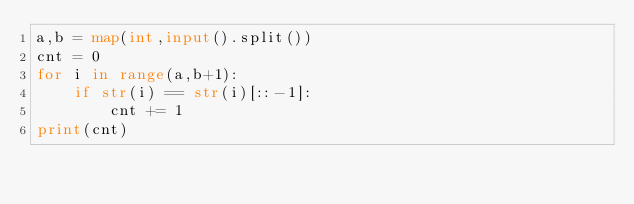<code> <loc_0><loc_0><loc_500><loc_500><_Python_>a,b = map(int,input().split())
cnt = 0
for i in range(a,b+1):
    if str(i) == str(i)[::-1]:
        cnt += 1
print(cnt)</code> 